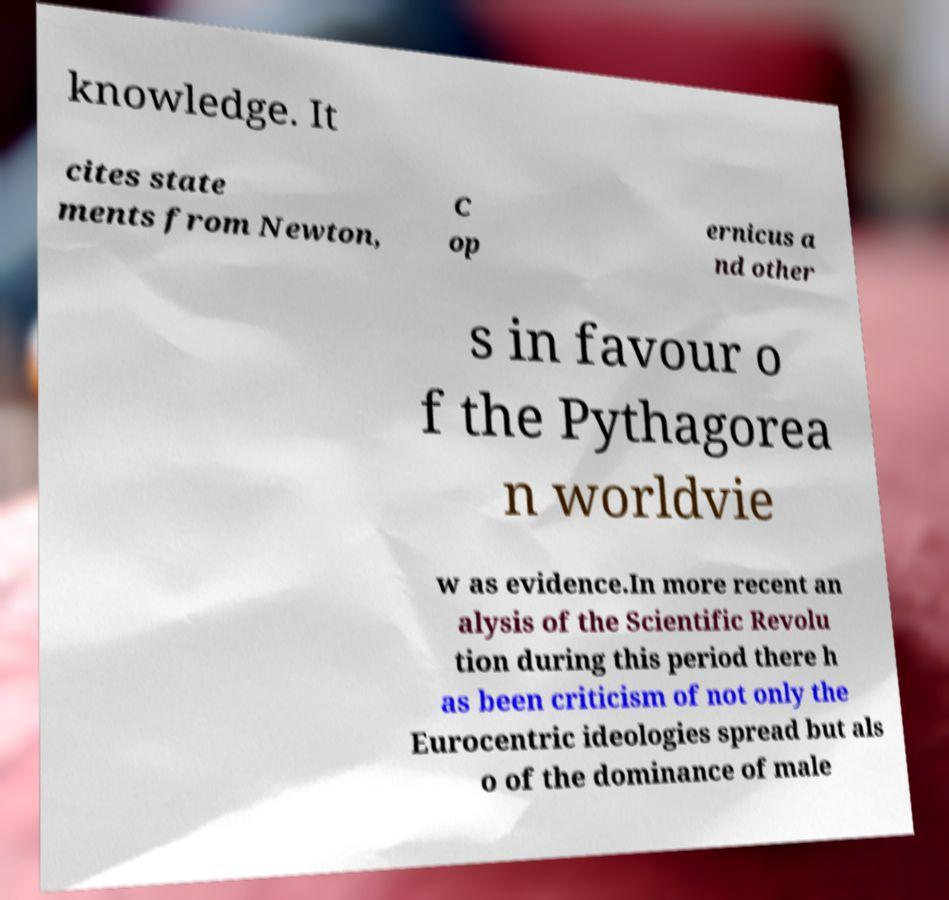Can you read and provide the text displayed in the image?This photo seems to have some interesting text. Can you extract and type it out for me? knowledge. It cites state ments from Newton, C op ernicus a nd other s in favour o f the Pythagorea n worldvie w as evidence.In more recent an alysis of the Scientific Revolu tion during this period there h as been criticism of not only the Eurocentric ideologies spread but als o of the dominance of male 